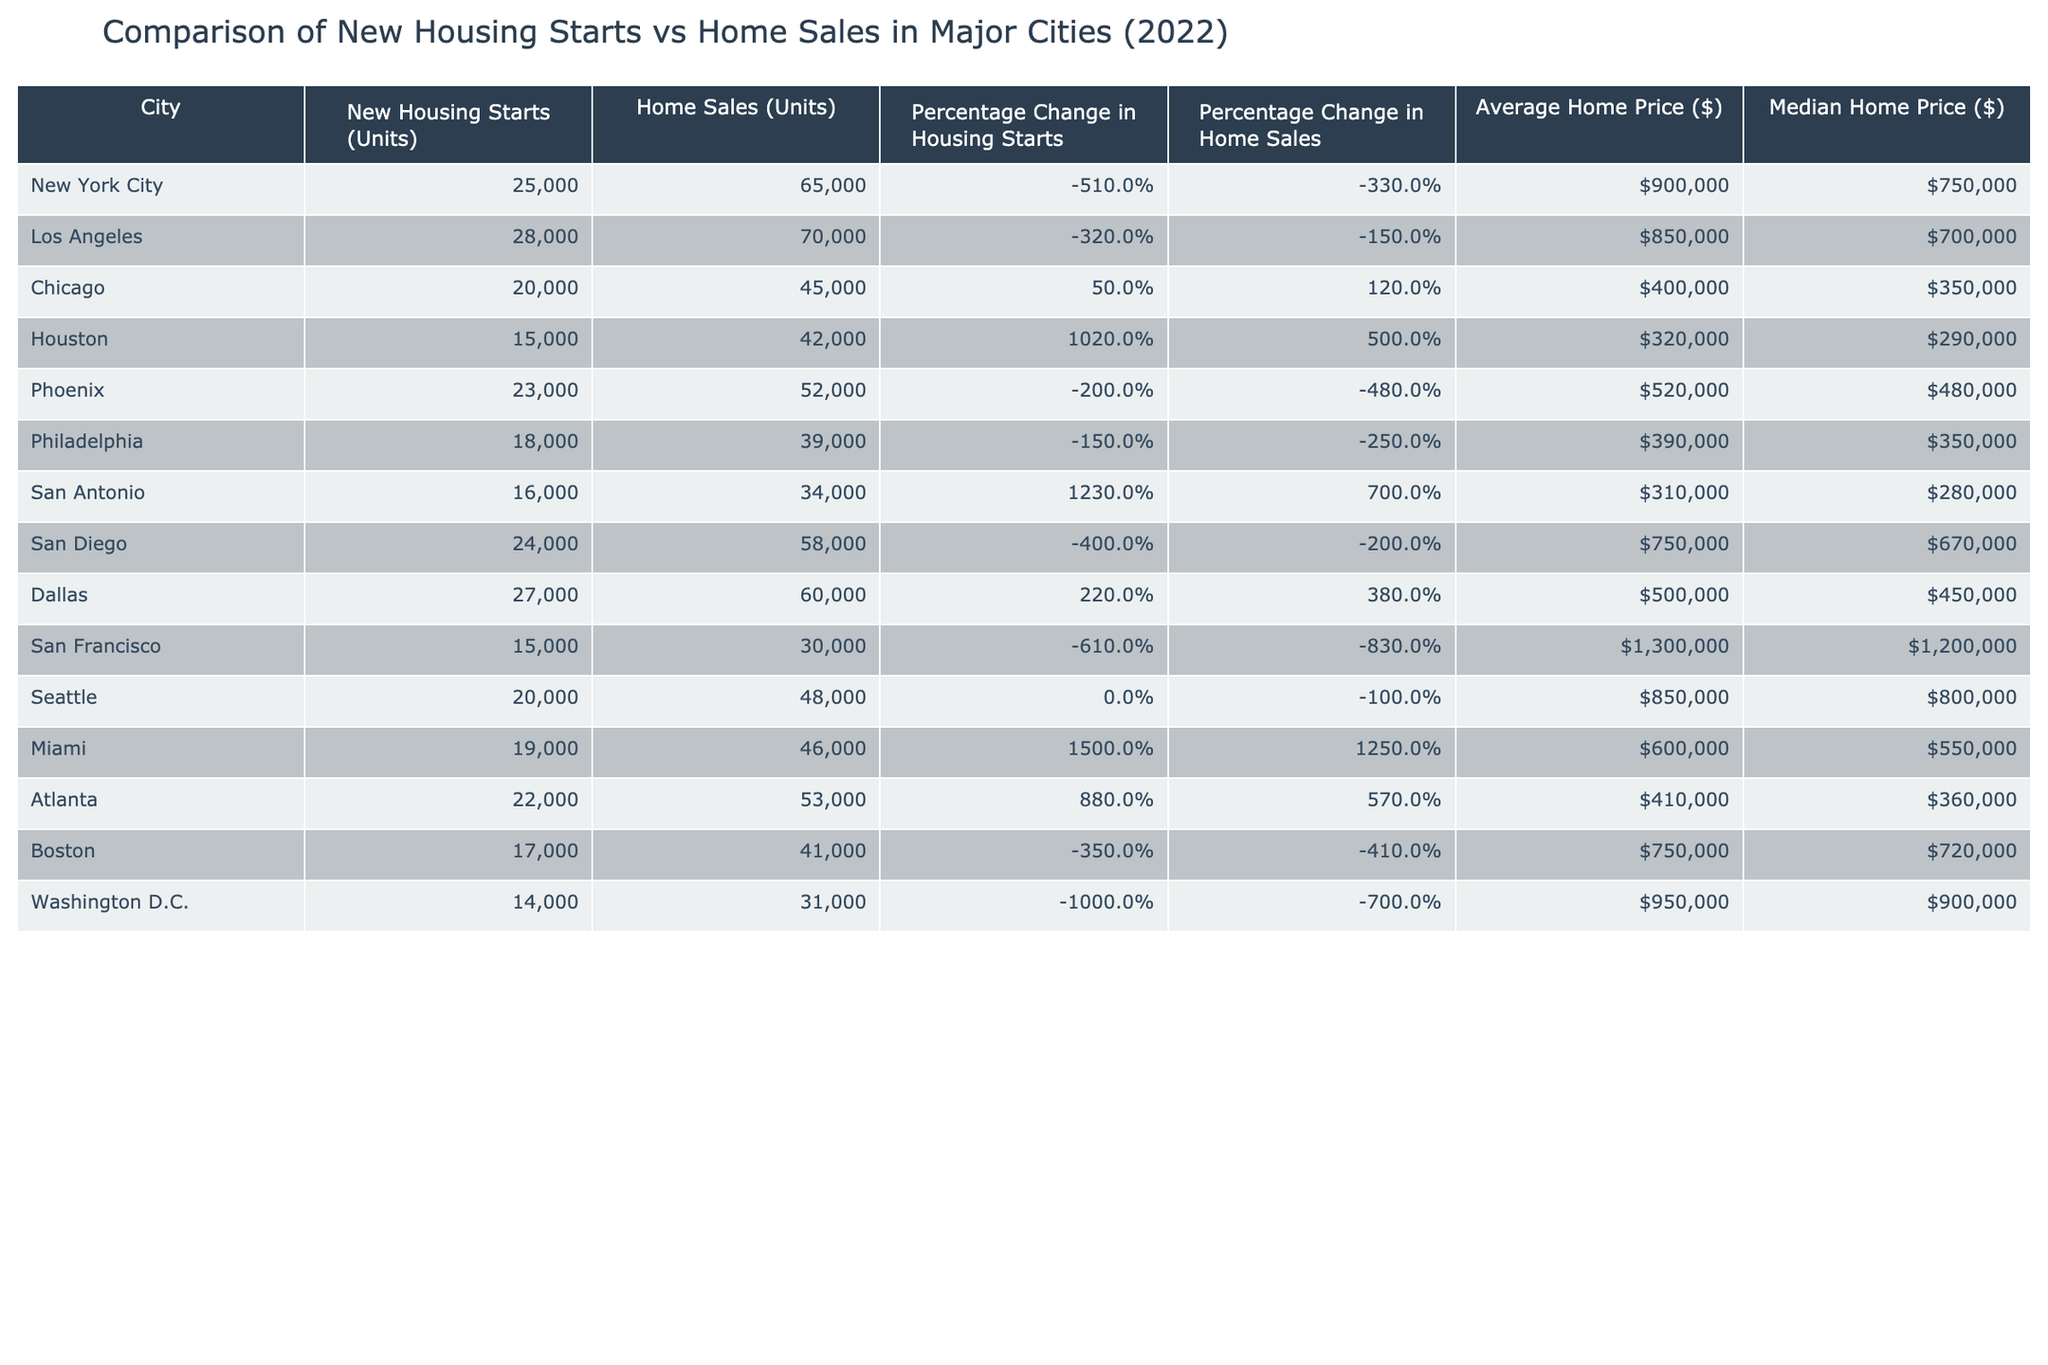What city had the highest number of new housing starts in 2022? The table indicates that Los Angeles had the highest new housing starts with 28,000 units.
Answer: Los Angeles Which city had the lowest home sales in 2022? According to the table, San Francisco had the lowest home sales with 30,000 units.
Answer: San Francisco What was the percentage change in home sales for Houston in 2022? The table shows that Houston had a percentage change in home sales of 5.0%.
Answer: 5.0% Which city's average home price was above $1 million in 2022? The table specifies that San Francisco's average home price was $1,300,000, which is above $1 million.
Answer: San Francisco What is the difference in new housing starts between New York City and Chicago? New York City had 25,000 new housing starts, while Chicago had 20,000. The difference is 25,000 - 20,000 = 5,000 units.
Answer: 5,000 units What was the median home price in Atlanta compared to the median home price in Philadelphia? The median home price in Atlanta is $360,000, whereas Philadelphia's median is $350,000. The difference is $360,000 - $350,000 = $10,000.
Answer: $10,000 Did Miami experience an increase or decrease in new housing starts from the previous year? The table indicates Miami had a percentage change in new housing starts of 15.0%, which means there was an increase.
Answer: Increase Which city had both more new housing starts than home sales and a percentage increase in housing starts? San Antonio had 16,000 new housing starts compared to 34,000 home sales, plus a percentage increase of 12.3%.
Answer: San Antonio If we average the average home prices of all cities listed, what would that result in? By adding the average home prices ($900,000 + $850,000 + $400,000 + $320,000 + $520,000 + $390,000 + $310,000 + $750,000 + $1,300,000 + $850,000 + $600,000 + $410,000 + $750,000 + $950,000) we get a sum of $8,090,000 and dividing by 13 gives an average of $623,846.
Answer: $623,846 What percentage change in home sales did San Diego experience in 2022 compared to the previous year? According to the table, San Diego saw a percentage change in home sales of -2.0%, indicating a decrease in home sales.
Answer: -2.0% 